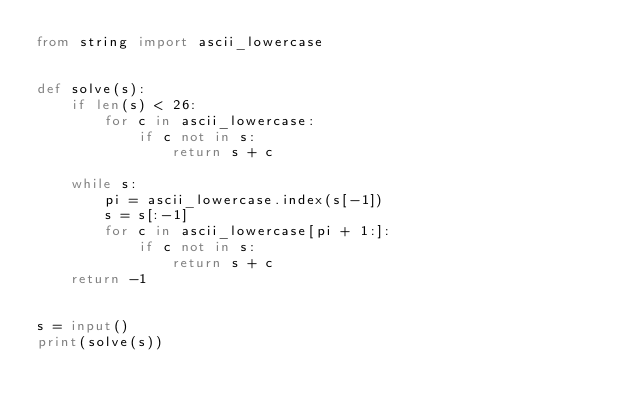<code> <loc_0><loc_0><loc_500><loc_500><_Python_>from string import ascii_lowercase


def solve(s):
    if len(s) < 26:
        for c in ascii_lowercase:
            if c not in s:
                return s + c

    while s:
        pi = ascii_lowercase.index(s[-1])
        s = s[:-1]
        for c in ascii_lowercase[pi + 1:]:
            if c not in s:
                return s + c
    return -1


s = input()
print(solve(s))
</code> 